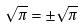Convert formula to latex. <formula><loc_0><loc_0><loc_500><loc_500>\sqrt { \pi } = \pm \sqrt { \pi }</formula> 